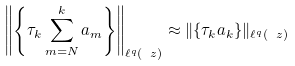Convert formula to latex. <formula><loc_0><loc_0><loc_500><loc_500>\left \| \left \{ \tau _ { k } \sum _ { m = N } ^ { k } a _ { m } \right \} \right \| _ { \ell ^ { q } ( \ z ) } \approx \| \{ \tau _ { k } a _ { k } \} \| _ { \ell ^ { q } ( \ z ) }</formula> 